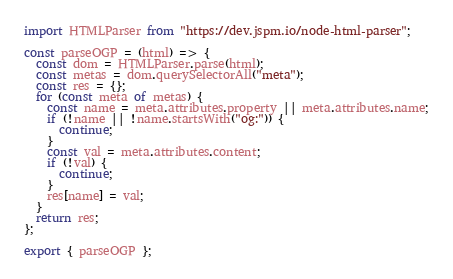Convert code to text. <code><loc_0><loc_0><loc_500><loc_500><_JavaScript_>import HTMLParser from "https://dev.jspm.io/node-html-parser";

const parseOGP = (html) => {
  const dom = HTMLParser.parse(html);
  const metas = dom.querySelectorAll("meta");
  const res = {};
  for (const meta of metas) {
    const name = meta.attributes.property || meta.attributes.name;
    if (!name || !name.startsWith("og:")) {
      continue;
    }
    const val = meta.attributes.content;
    if (!val) {
      continue;
    }
    res[name] = val;
  }
  return res;
};

export { parseOGP };
</code> 